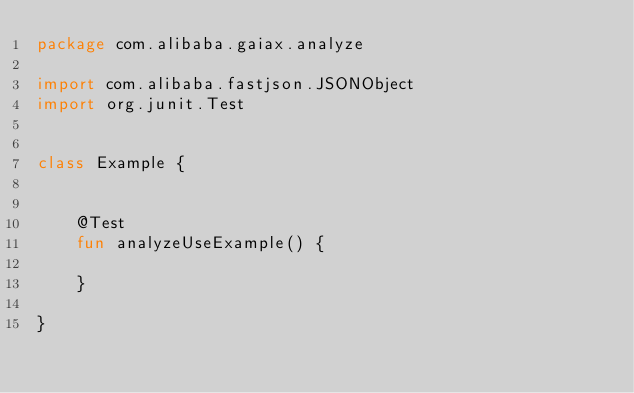Convert code to text. <code><loc_0><loc_0><loc_500><loc_500><_Kotlin_>package com.alibaba.gaiax.analyze

import com.alibaba.fastjson.JSONObject
import org.junit.Test


class Example {


    @Test
    fun analyzeUseExample() {

    }

}
</code> 